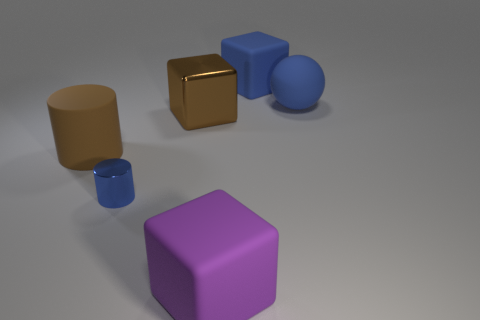What materials are the objects in the image made of and how can you tell? The image displays objects that appear to be made of different materials. The small and large cubes seem to have a metallic finish, indicating they could be made of metal due to their reflective surface. The blue cylinder and the sphere have a matte finish, suggesting a rubber or plastic material. Lastly, the tan cylinder has a less reflective matte surface, which could imply a clay or stone-like composition. 